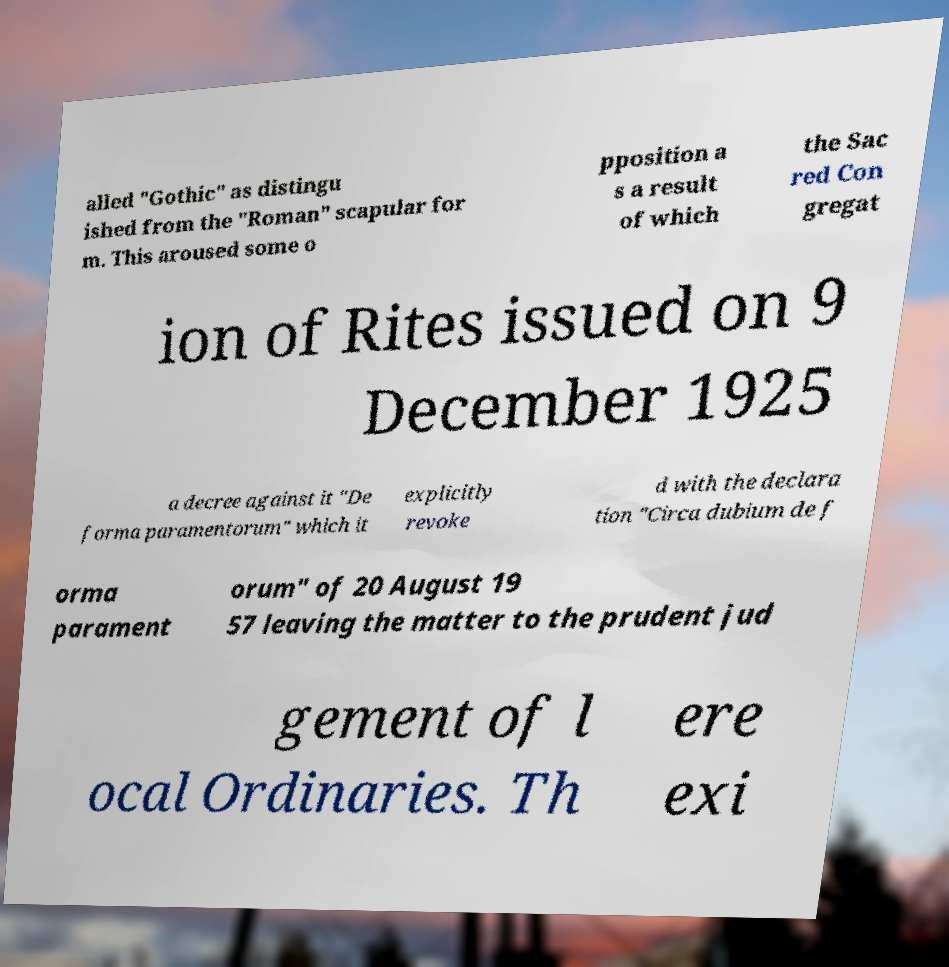Can you accurately transcribe the text from the provided image for me? alled "Gothic" as distingu ished from the "Roman" scapular for m. This aroused some o pposition a s a result of which the Sac red Con gregat ion of Rites issued on 9 December 1925 a decree against it "De forma paramentorum" which it explicitly revoke d with the declara tion "Circa dubium de f orma parament orum" of 20 August 19 57 leaving the matter to the prudent jud gement of l ocal Ordinaries. Th ere exi 